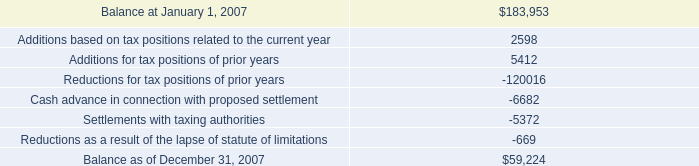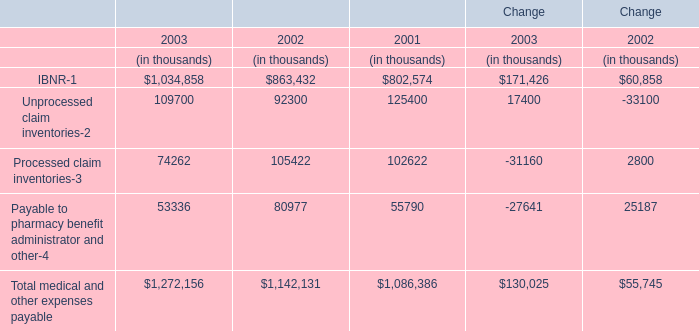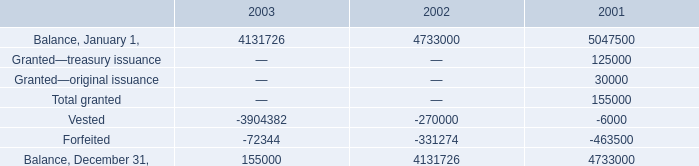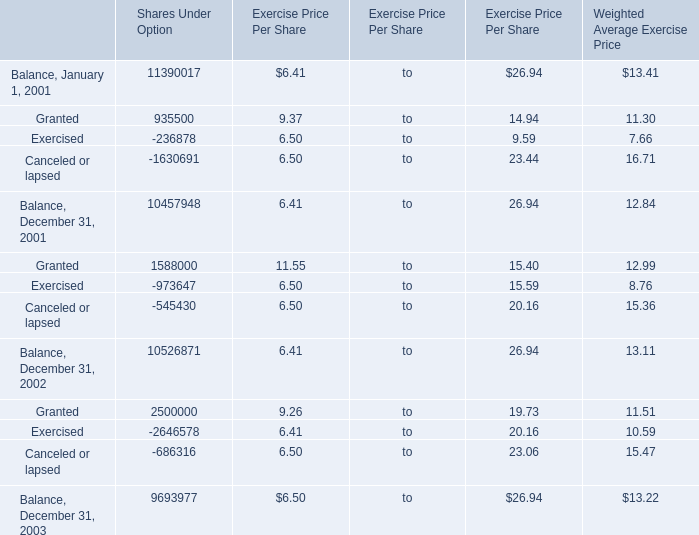what is the percentage change in he total amount of accrued income tax-related interest and penalties included in other long-term liabilities during 2007? 
Computations: ((30.7 - 33.2) / 33.2)
Answer: -0.0753. 